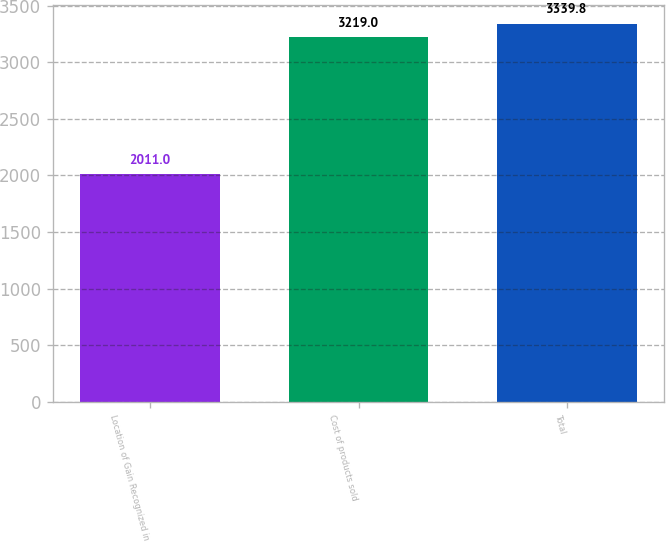Convert chart. <chart><loc_0><loc_0><loc_500><loc_500><bar_chart><fcel>Location of Gain Recognized in<fcel>Cost of products sold<fcel>Total<nl><fcel>2011<fcel>3219<fcel>3339.8<nl></chart> 